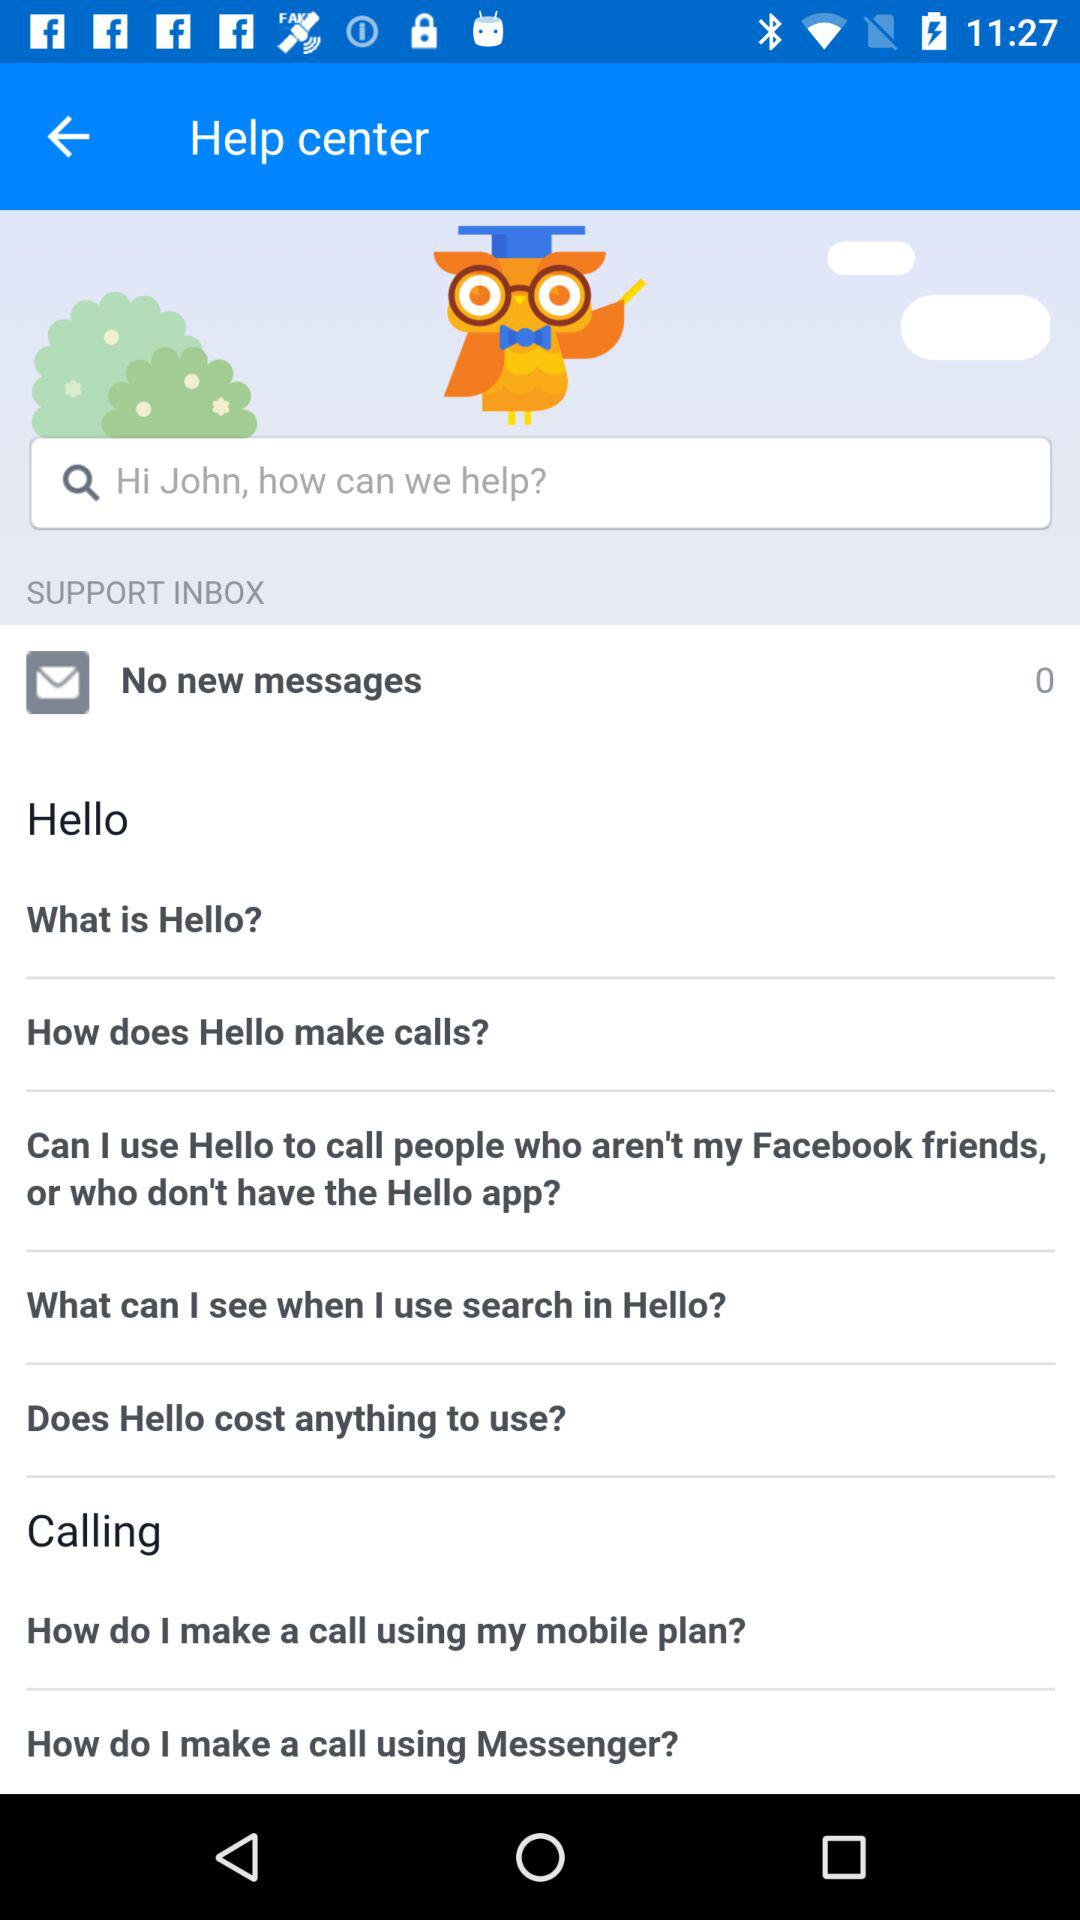How many messages are shown there? There are 0 messages. 